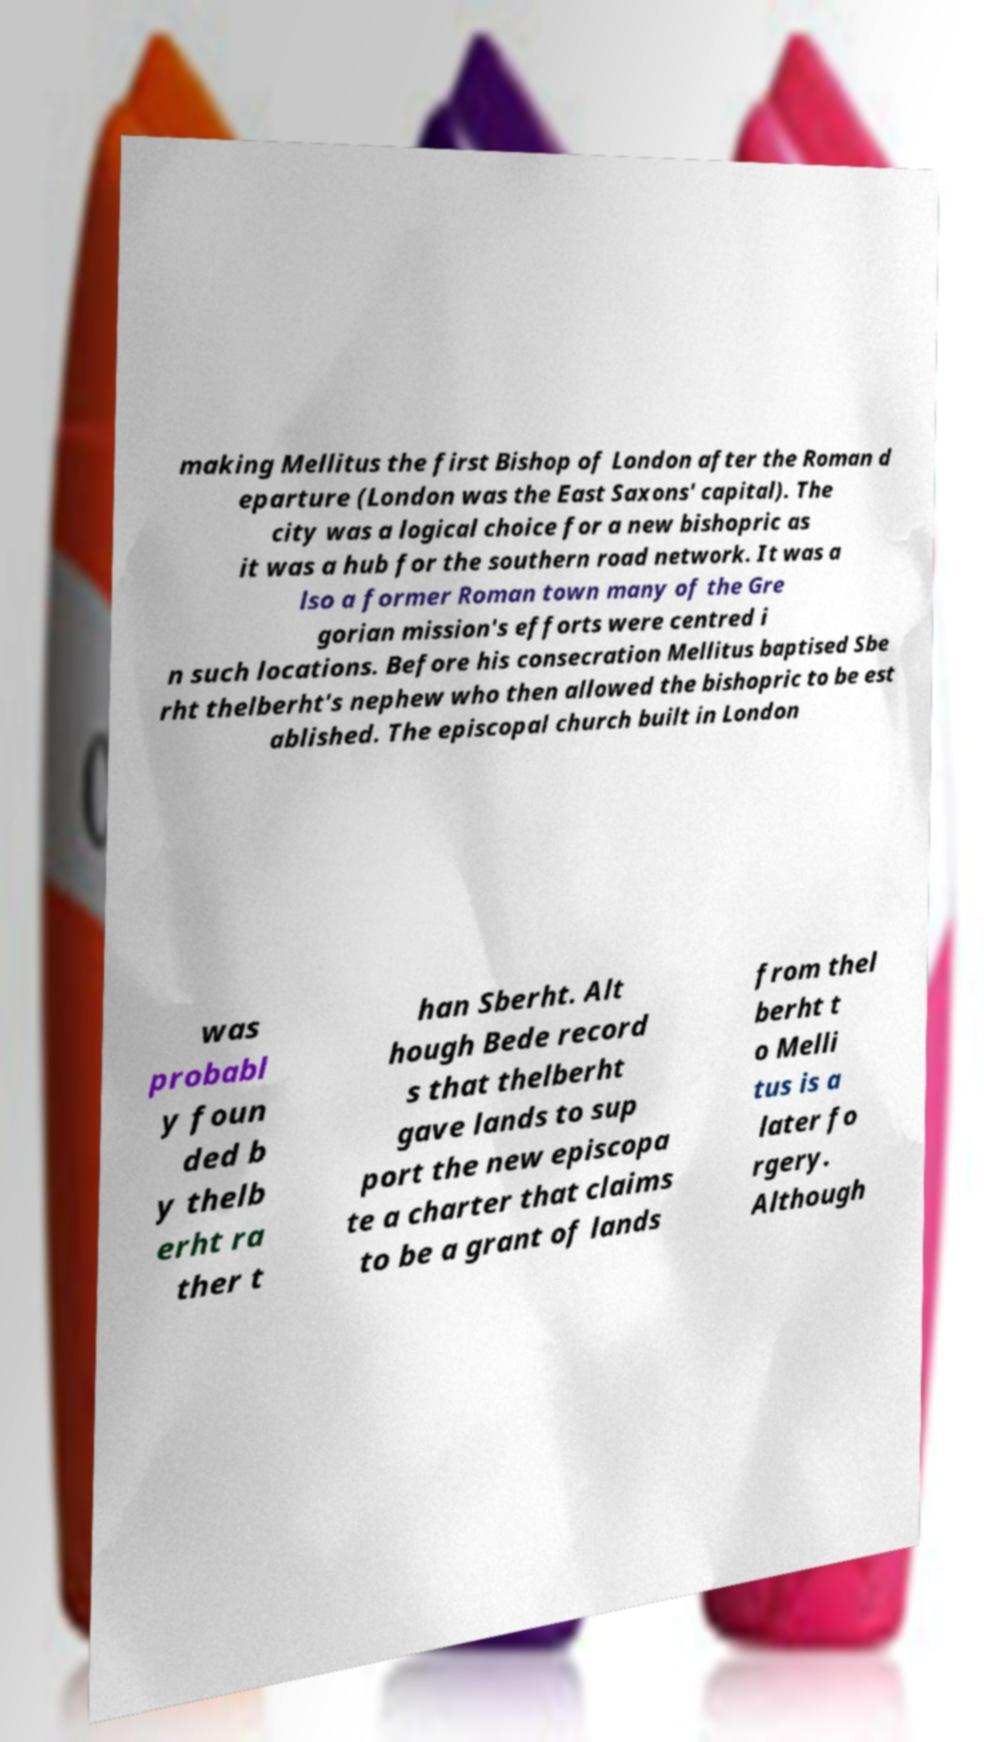Can you accurately transcribe the text from the provided image for me? making Mellitus the first Bishop of London after the Roman d eparture (London was the East Saxons' capital). The city was a logical choice for a new bishopric as it was a hub for the southern road network. It was a lso a former Roman town many of the Gre gorian mission's efforts were centred i n such locations. Before his consecration Mellitus baptised Sbe rht thelberht's nephew who then allowed the bishopric to be est ablished. The episcopal church built in London was probabl y foun ded b y thelb erht ra ther t han Sberht. Alt hough Bede record s that thelberht gave lands to sup port the new episcopa te a charter that claims to be a grant of lands from thel berht t o Melli tus is a later fo rgery. Although 